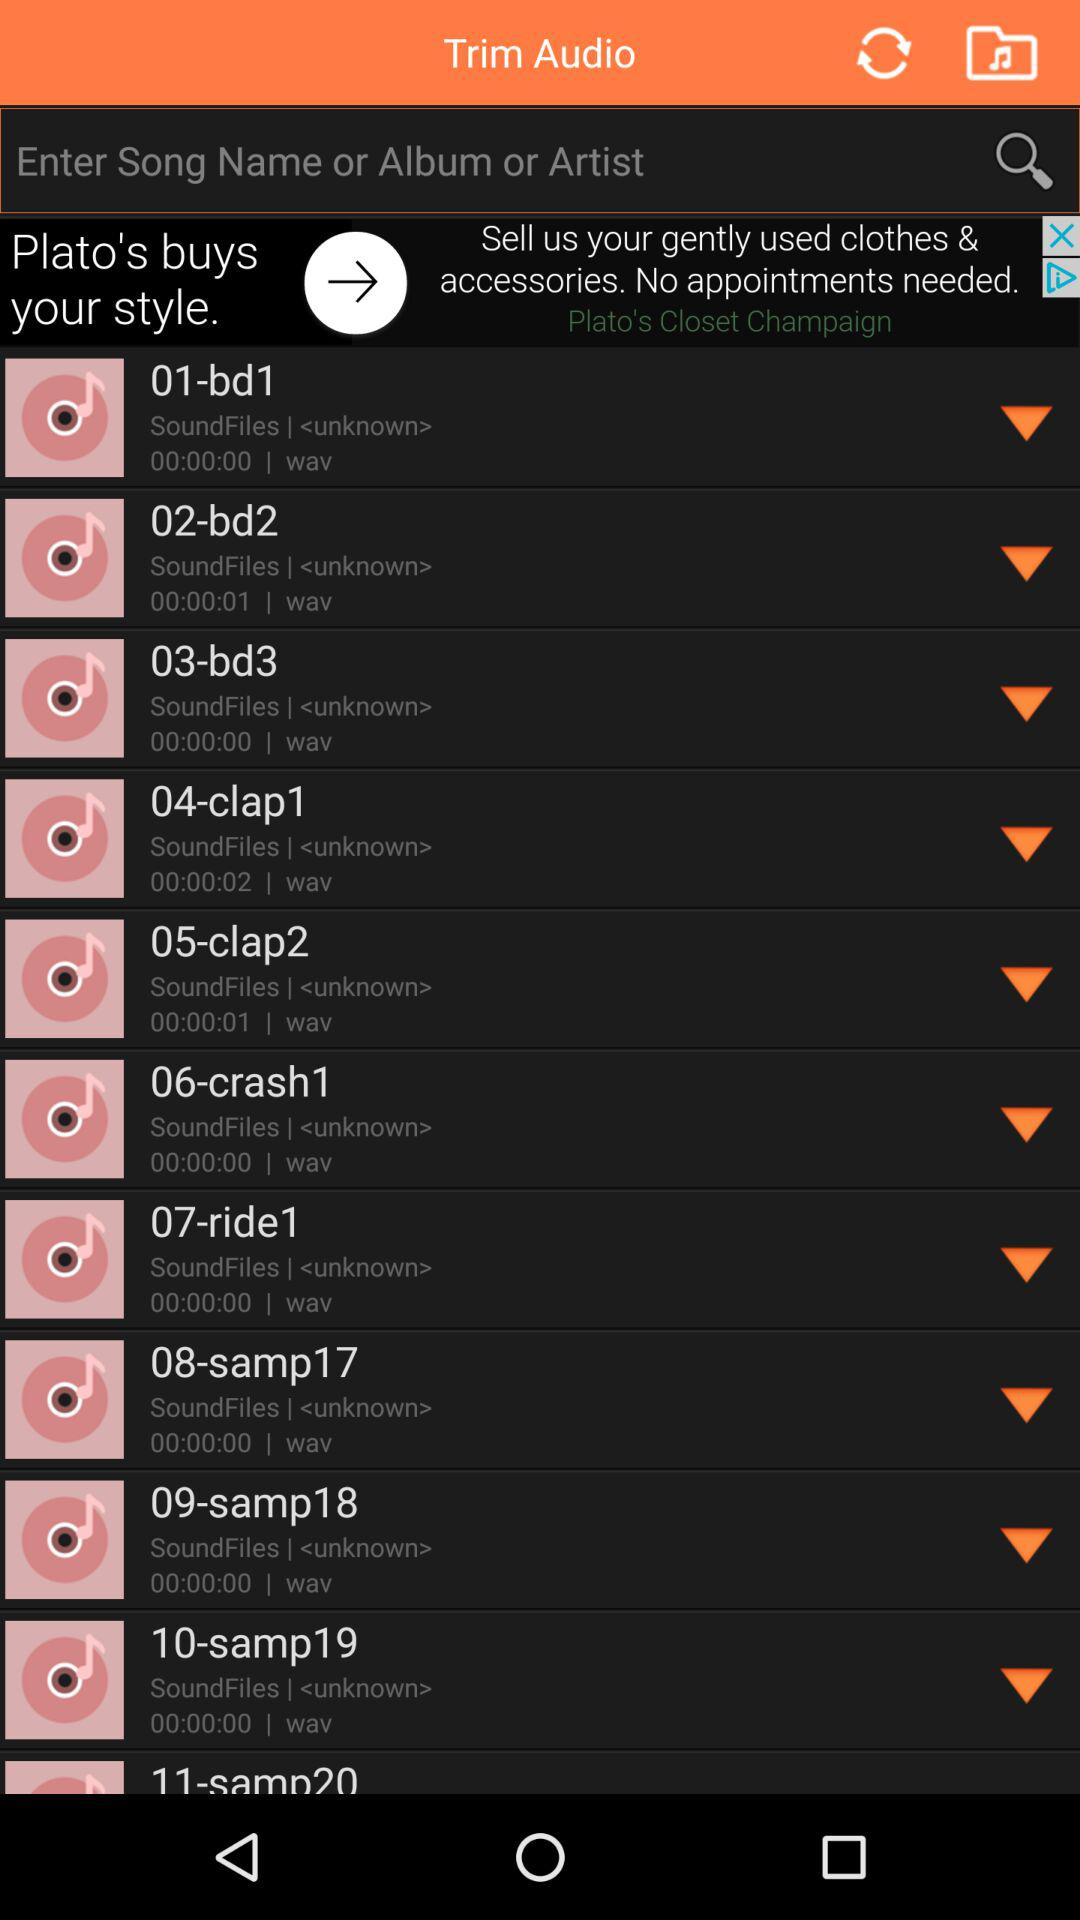What is the time duration of the audio "05-clap2"? The time duration of the audio "05-clap2" is 1 second. 